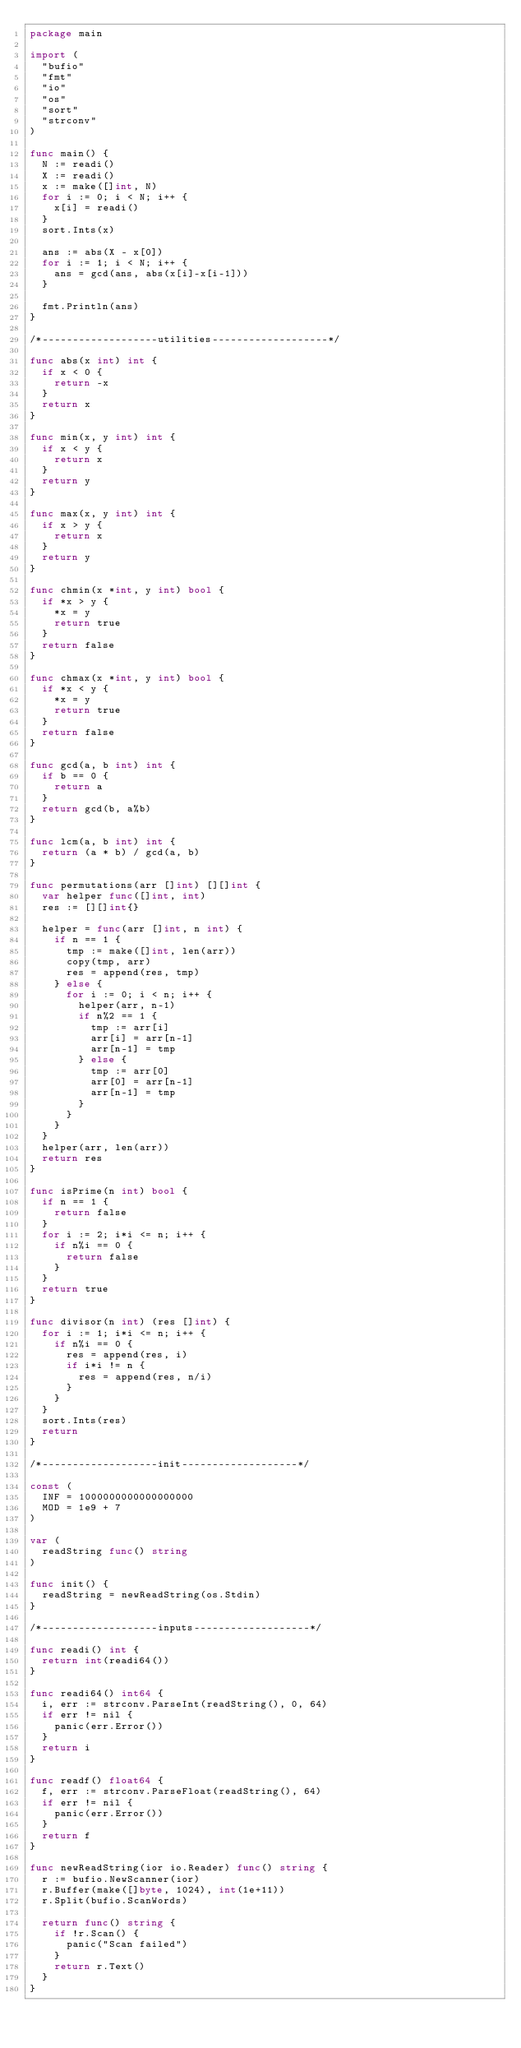<code> <loc_0><loc_0><loc_500><loc_500><_Go_>package main

import (
	"bufio"
	"fmt"
	"io"
	"os"
	"sort"
	"strconv"
)

func main() {
	N := readi()
	X := readi()
	x := make([]int, N)
	for i := 0; i < N; i++ {
		x[i] = readi()
	}
	sort.Ints(x)

	ans := abs(X - x[0])
	for i := 1; i < N; i++ {
		ans = gcd(ans, abs(x[i]-x[i-1]))
	}

	fmt.Println(ans)
}

/*-------------------utilities-------------------*/

func abs(x int) int {
	if x < 0 {
		return -x
	}
	return x
}

func min(x, y int) int {
	if x < y {
		return x
	}
	return y
}

func max(x, y int) int {
	if x > y {
		return x
	}
	return y
}

func chmin(x *int, y int) bool {
	if *x > y {
		*x = y
		return true
	}
	return false
}

func chmax(x *int, y int) bool {
	if *x < y {
		*x = y
		return true
	}
	return false
}

func gcd(a, b int) int {
	if b == 0 {
		return a
	}
	return gcd(b, a%b)
}

func lcm(a, b int) int {
	return (a * b) / gcd(a, b)
}

func permutations(arr []int) [][]int {
	var helper func([]int, int)
	res := [][]int{}

	helper = func(arr []int, n int) {
		if n == 1 {
			tmp := make([]int, len(arr))
			copy(tmp, arr)
			res = append(res, tmp)
		} else {
			for i := 0; i < n; i++ {
				helper(arr, n-1)
				if n%2 == 1 {
					tmp := arr[i]
					arr[i] = arr[n-1]
					arr[n-1] = tmp
				} else {
					tmp := arr[0]
					arr[0] = arr[n-1]
					arr[n-1] = tmp
				}
			}
		}
	}
	helper(arr, len(arr))
	return res
}

func isPrime(n int) bool {
	if n == 1 {
		return false
	}
	for i := 2; i*i <= n; i++ {
		if n%i == 0 {
			return false
		}
	}
	return true
}

func divisor(n int) (res []int) {
	for i := 1; i*i <= n; i++ {
		if n%i == 0 {
			res = append(res, i)
			if i*i != n {
				res = append(res, n/i)
			}
		}
	}
	sort.Ints(res)
	return
}

/*-------------------init-------------------*/

const (
	INF = 1000000000000000000
	MOD = 1e9 + 7
)

var (
	readString func() string
)

func init() {
	readString = newReadString(os.Stdin)
}

/*-------------------inputs-------------------*/

func readi() int {
	return int(readi64())
}

func readi64() int64 {
	i, err := strconv.ParseInt(readString(), 0, 64)
	if err != nil {
		panic(err.Error())
	}
	return i
}

func readf() float64 {
	f, err := strconv.ParseFloat(readString(), 64)
	if err != nil {
		panic(err.Error())
	}
	return f
}

func newReadString(ior io.Reader) func() string {
	r := bufio.NewScanner(ior)
	r.Buffer(make([]byte, 1024), int(1e+11))
	r.Split(bufio.ScanWords)

	return func() string {
		if !r.Scan() {
			panic("Scan failed")
		}
		return r.Text()
	}
}
</code> 